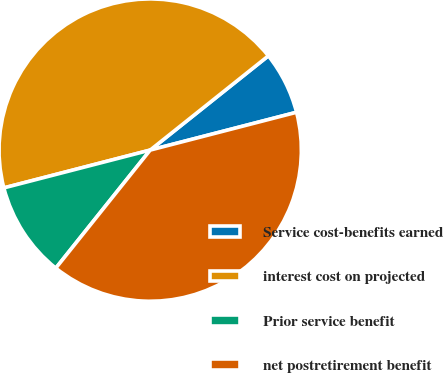Convert chart to OTSL. <chart><loc_0><loc_0><loc_500><loc_500><pie_chart><fcel>Service cost-benefits earned<fcel>interest cost on projected<fcel>Prior service benefit<fcel>net postretirement benefit<nl><fcel>6.69%<fcel>43.31%<fcel>10.24%<fcel>39.76%<nl></chart> 